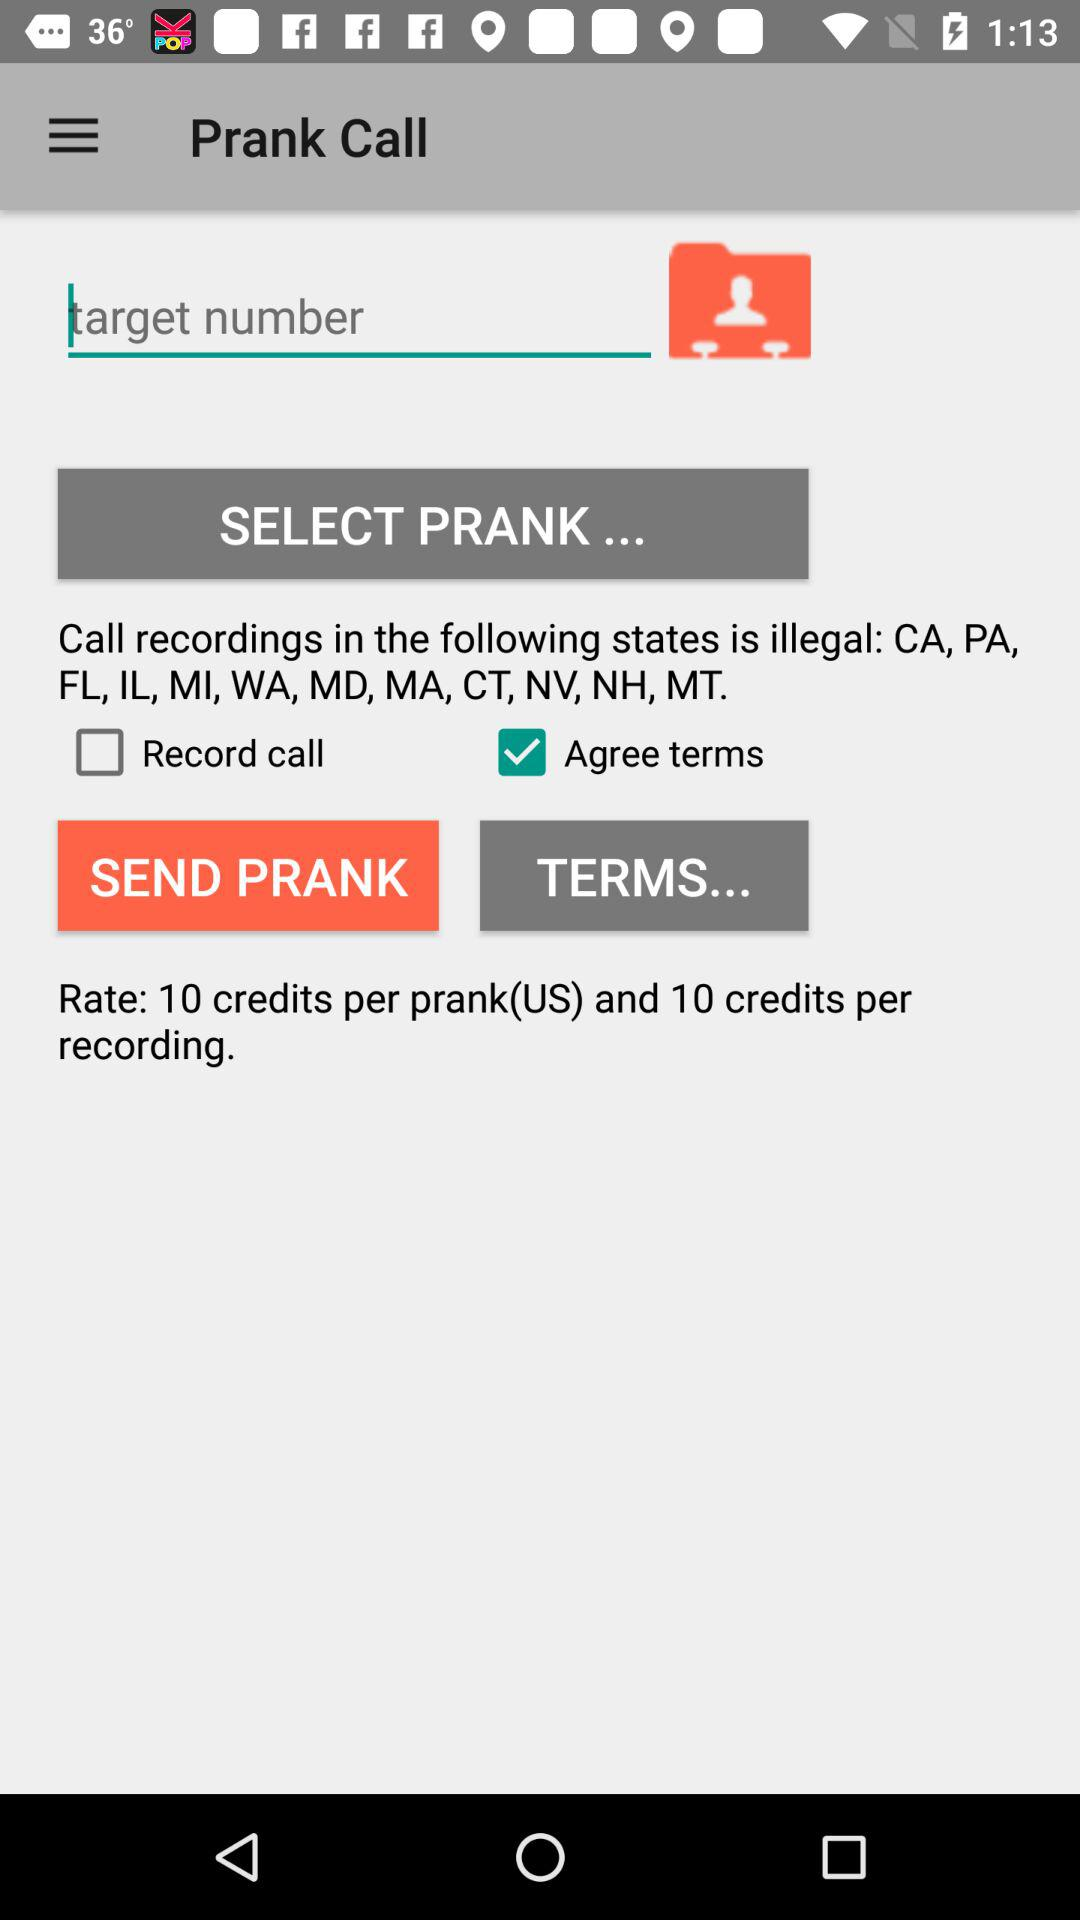What is the name of the application? The name of the application is "Prank Call". 